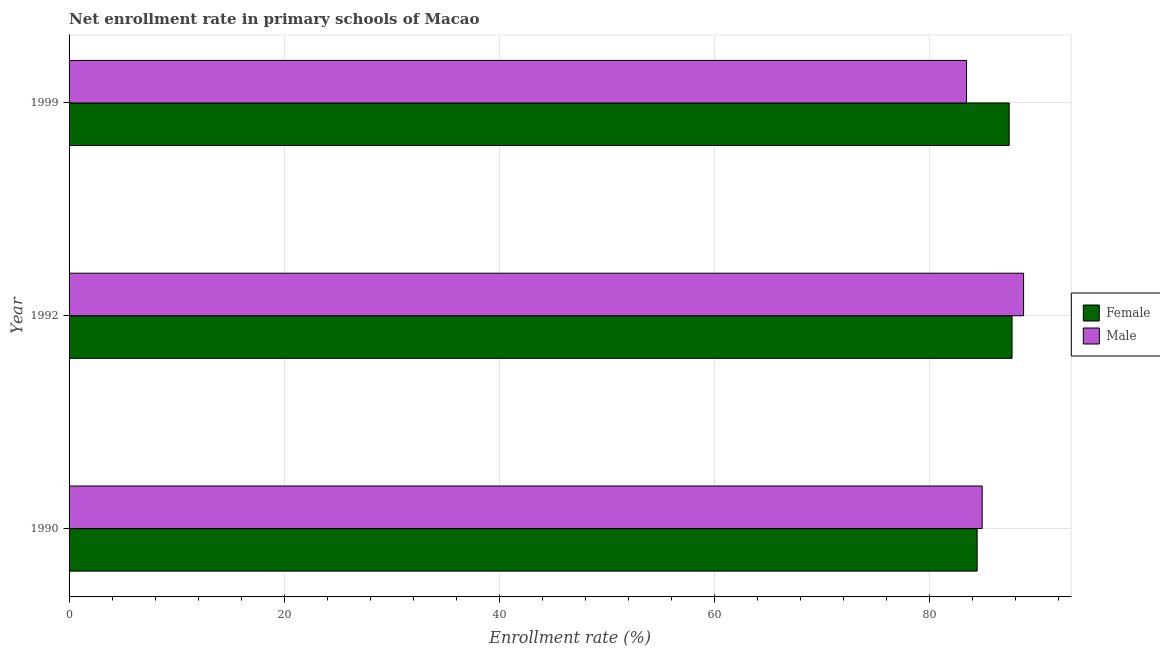Are the number of bars per tick equal to the number of legend labels?
Offer a terse response. Yes. Are the number of bars on each tick of the Y-axis equal?
Offer a terse response. Yes. How many bars are there on the 2nd tick from the top?
Offer a very short reply. 2. What is the enrollment rate of female students in 1999?
Give a very brief answer. 87.38. Across all years, what is the maximum enrollment rate of male students?
Keep it short and to the point. 88.71. Across all years, what is the minimum enrollment rate of female students?
Keep it short and to the point. 84.4. In which year was the enrollment rate of male students minimum?
Provide a short and direct response. 1999. What is the total enrollment rate of male students in the graph?
Offer a terse response. 256.99. What is the difference between the enrollment rate of male students in 1992 and that in 1999?
Your answer should be compact. 5.3. What is the difference between the enrollment rate of male students in 1990 and the enrollment rate of female students in 1999?
Your response must be concise. -2.51. What is the average enrollment rate of male students per year?
Your response must be concise. 85.66. In the year 1992, what is the difference between the enrollment rate of female students and enrollment rate of male students?
Make the answer very short. -1.07. In how many years, is the enrollment rate of female students greater than 56 %?
Your response must be concise. 3. What is the ratio of the enrollment rate of male students in 1990 to that in 1992?
Make the answer very short. 0.96. Is the enrollment rate of male students in 1990 less than that in 1999?
Make the answer very short. No. What is the difference between the highest and the second highest enrollment rate of female students?
Make the answer very short. 0.27. What is the difference between the highest and the lowest enrollment rate of female students?
Your answer should be very brief. 3.24. In how many years, is the enrollment rate of male students greater than the average enrollment rate of male students taken over all years?
Provide a succinct answer. 1. Is the sum of the enrollment rate of female students in 1992 and 1999 greater than the maximum enrollment rate of male students across all years?
Offer a very short reply. Yes. What does the 1st bar from the top in 1999 represents?
Ensure brevity in your answer.  Male. How many bars are there?
Ensure brevity in your answer.  6. What is the difference between two consecutive major ticks on the X-axis?
Give a very brief answer. 20. Does the graph contain any zero values?
Provide a short and direct response. No. How are the legend labels stacked?
Your answer should be very brief. Vertical. What is the title of the graph?
Ensure brevity in your answer.  Net enrollment rate in primary schools of Macao. Does "Under five" appear as one of the legend labels in the graph?
Offer a terse response. No. What is the label or title of the X-axis?
Provide a succinct answer. Enrollment rate (%). What is the label or title of the Y-axis?
Your answer should be very brief. Year. What is the Enrollment rate (%) of Female in 1990?
Your answer should be compact. 84.4. What is the Enrollment rate (%) in Male in 1990?
Your answer should be very brief. 84.87. What is the Enrollment rate (%) in Female in 1992?
Offer a terse response. 87.64. What is the Enrollment rate (%) in Male in 1992?
Your answer should be very brief. 88.71. What is the Enrollment rate (%) in Female in 1999?
Your response must be concise. 87.38. What is the Enrollment rate (%) in Male in 1999?
Ensure brevity in your answer.  83.41. Across all years, what is the maximum Enrollment rate (%) in Female?
Your response must be concise. 87.64. Across all years, what is the maximum Enrollment rate (%) of Male?
Provide a succinct answer. 88.71. Across all years, what is the minimum Enrollment rate (%) of Female?
Make the answer very short. 84.4. Across all years, what is the minimum Enrollment rate (%) in Male?
Provide a succinct answer. 83.41. What is the total Enrollment rate (%) of Female in the graph?
Ensure brevity in your answer.  259.42. What is the total Enrollment rate (%) of Male in the graph?
Your answer should be very brief. 256.99. What is the difference between the Enrollment rate (%) of Female in 1990 and that in 1992?
Offer a terse response. -3.24. What is the difference between the Enrollment rate (%) of Male in 1990 and that in 1992?
Your response must be concise. -3.85. What is the difference between the Enrollment rate (%) of Female in 1990 and that in 1999?
Ensure brevity in your answer.  -2.98. What is the difference between the Enrollment rate (%) of Male in 1990 and that in 1999?
Make the answer very short. 1.46. What is the difference between the Enrollment rate (%) of Female in 1992 and that in 1999?
Offer a very short reply. 0.27. What is the difference between the Enrollment rate (%) of Male in 1992 and that in 1999?
Provide a short and direct response. 5.3. What is the difference between the Enrollment rate (%) in Female in 1990 and the Enrollment rate (%) in Male in 1992?
Keep it short and to the point. -4.32. What is the difference between the Enrollment rate (%) of Female in 1990 and the Enrollment rate (%) of Male in 1999?
Your answer should be very brief. 0.99. What is the difference between the Enrollment rate (%) in Female in 1992 and the Enrollment rate (%) in Male in 1999?
Provide a succinct answer. 4.23. What is the average Enrollment rate (%) in Female per year?
Provide a succinct answer. 86.47. What is the average Enrollment rate (%) of Male per year?
Offer a very short reply. 85.66. In the year 1990, what is the difference between the Enrollment rate (%) of Female and Enrollment rate (%) of Male?
Offer a terse response. -0.47. In the year 1992, what is the difference between the Enrollment rate (%) in Female and Enrollment rate (%) in Male?
Keep it short and to the point. -1.07. In the year 1999, what is the difference between the Enrollment rate (%) of Female and Enrollment rate (%) of Male?
Provide a short and direct response. 3.96. What is the ratio of the Enrollment rate (%) of Female in 1990 to that in 1992?
Provide a short and direct response. 0.96. What is the ratio of the Enrollment rate (%) of Male in 1990 to that in 1992?
Make the answer very short. 0.96. What is the ratio of the Enrollment rate (%) in Female in 1990 to that in 1999?
Your answer should be very brief. 0.97. What is the ratio of the Enrollment rate (%) in Male in 1990 to that in 1999?
Your answer should be compact. 1.02. What is the ratio of the Enrollment rate (%) in Male in 1992 to that in 1999?
Give a very brief answer. 1.06. What is the difference between the highest and the second highest Enrollment rate (%) in Female?
Offer a terse response. 0.27. What is the difference between the highest and the second highest Enrollment rate (%) of Male?
Provide a succinct answer. 3.85. What is the difference between the highest and the lowest Enrollment rate (%) of Female?
Offer a terse response. 3.24. What is the difference between the highest and the lowest Enrollment rate (%) of Male?
Make the answer very short. 5.3. 